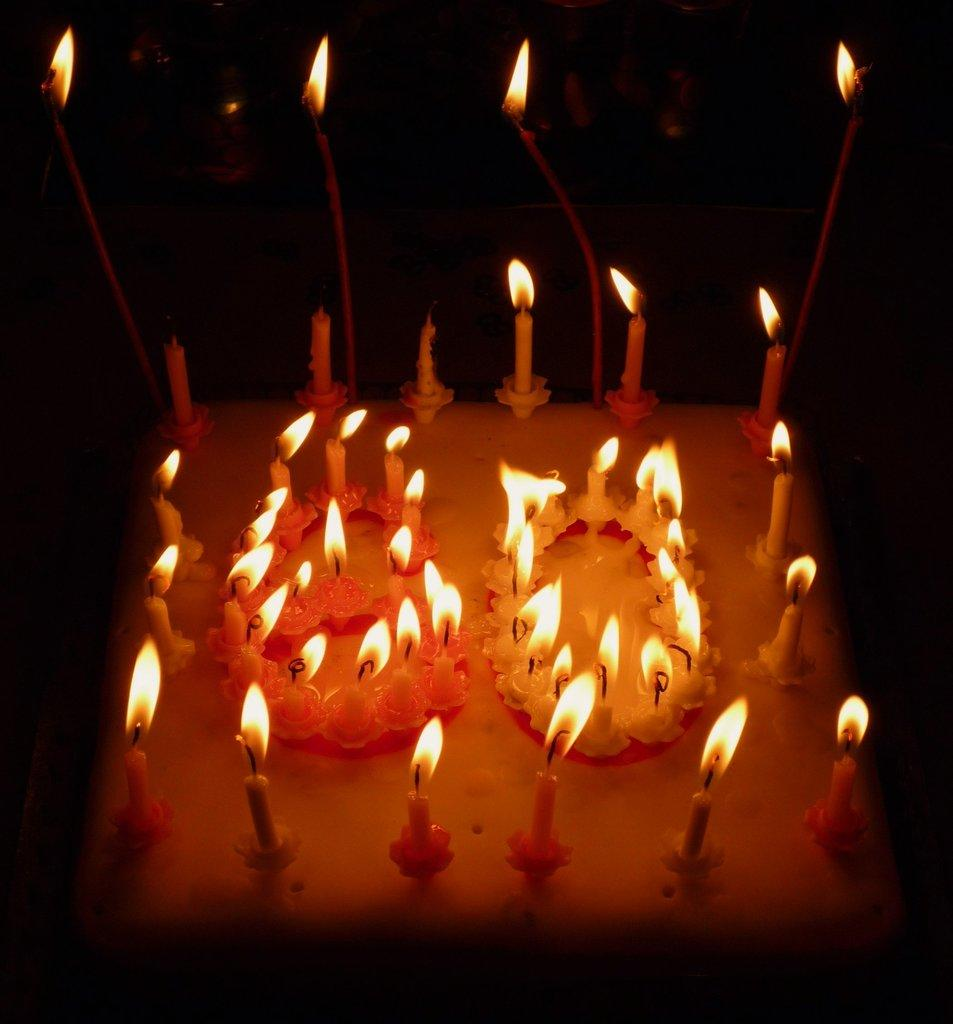What is the main subject of the image? The main subject of the image is a cake with candles. Where are the candles located on the cake? The candles are in the center of the cake. What historical event is depicted on the map in the image? There is no map present in the image, so it is not possible to answer that question. 